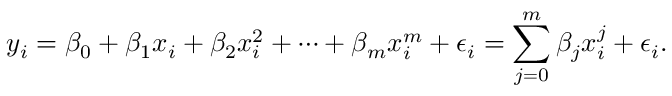<formula> <loc_0><loc_0><loc_500><loc_500>y _ { i } = \beta _ { 0 } + \beta _ { 1 } x _ { i } + \beta _ { 2 } x _ { i } ^ { 2 } + \cdots + \beta _ { m } x _ { i } ^ { m } + \epsilon _ { i } = \sum _ { j = 0 } ^ { m } \beta _ { j } x _ { i } ^ { j } + \epsilon _ { i } .</formula> 